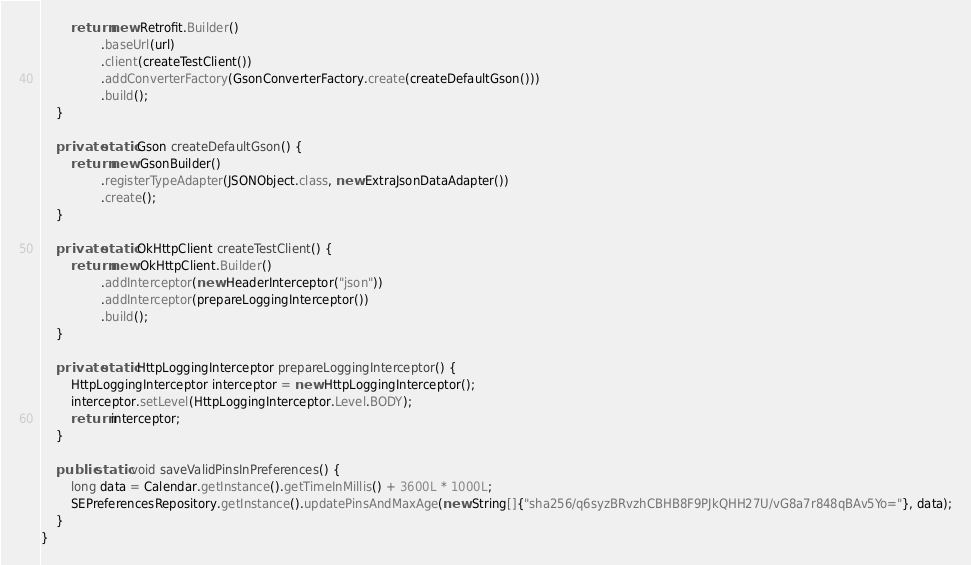<code> <loc_0><loc_0><loc_500><loc_500><_Java_>        return new Retrofit.Builder()
                .baseUrl(url)
                .client(createTestClient())
                .addConverterFactory(GsonConverterFactory.create(createDefaultGson()))
                .build();
    }

    private static Gson createDefaultGson() {
        return new GsonBuilder()
                .registerTypeAdapter(JSONObject.class, new ExtraJsonDataAdapter())
                .create();
    }

    private static OkHttpClient createTestClient() {
        return new OkHttpClient.Builder()
                .addInterceptor(new HeaderInterceptor("json"))
                .addInterceptor(prepareLoggingInterceptor())
                .build();
    }

    private static HttpLoggingInterceptor prepareLoggingInterceptor() {
        HttpLoggingInterceptor interceptor = new HttpLoggingInterceptor();
        interceptor.setLevel(HttpLoggingInterceptor.Level.BODY);
        return interceptor;
    }

    public static void saveValidPinsInPreferences() {
        long data = Calendar.getInstance().getTimeInMillis() + 3600L * 1000L;
        SEPreferencesRepository.getInstance().updatePinsAndMaxAge(new String[]{"sha256/q6syzBRvzhCBHB8F9PJkQHH27U/vG8a7r848qBAv5Yo="}, data);
    }
}
</code> 